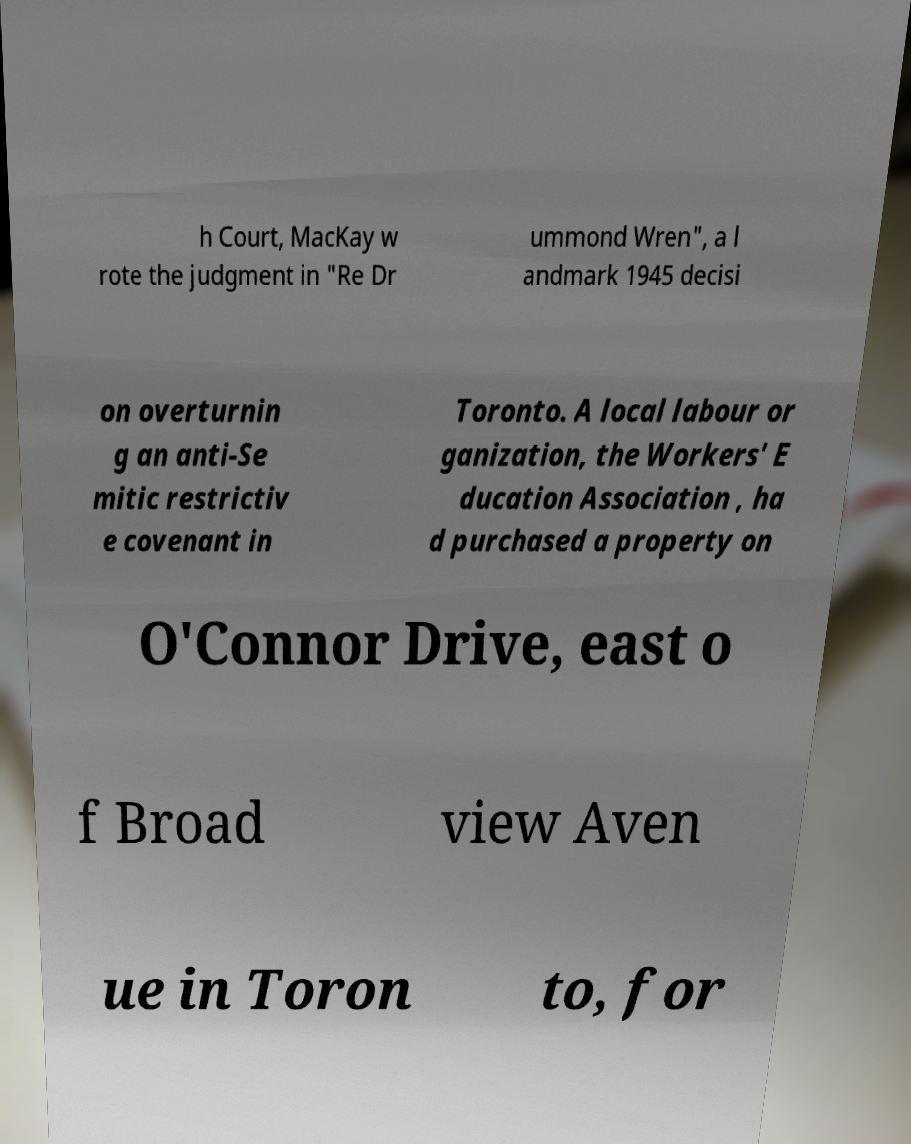I need the written content from this picture converted into text. Can you do that? h Court, MacKay w rote the judgment in "Re Dr ummond Wren", a l andmark 1945 decisi on overturnin g an anti-Se mitic restrictiv e covenant in Toronto. A local labour or ganization, the Workers' E ducation Association , ha d purchased a property on O'Connor Drive, east o f Broad view Aven ue in Toron to, for 